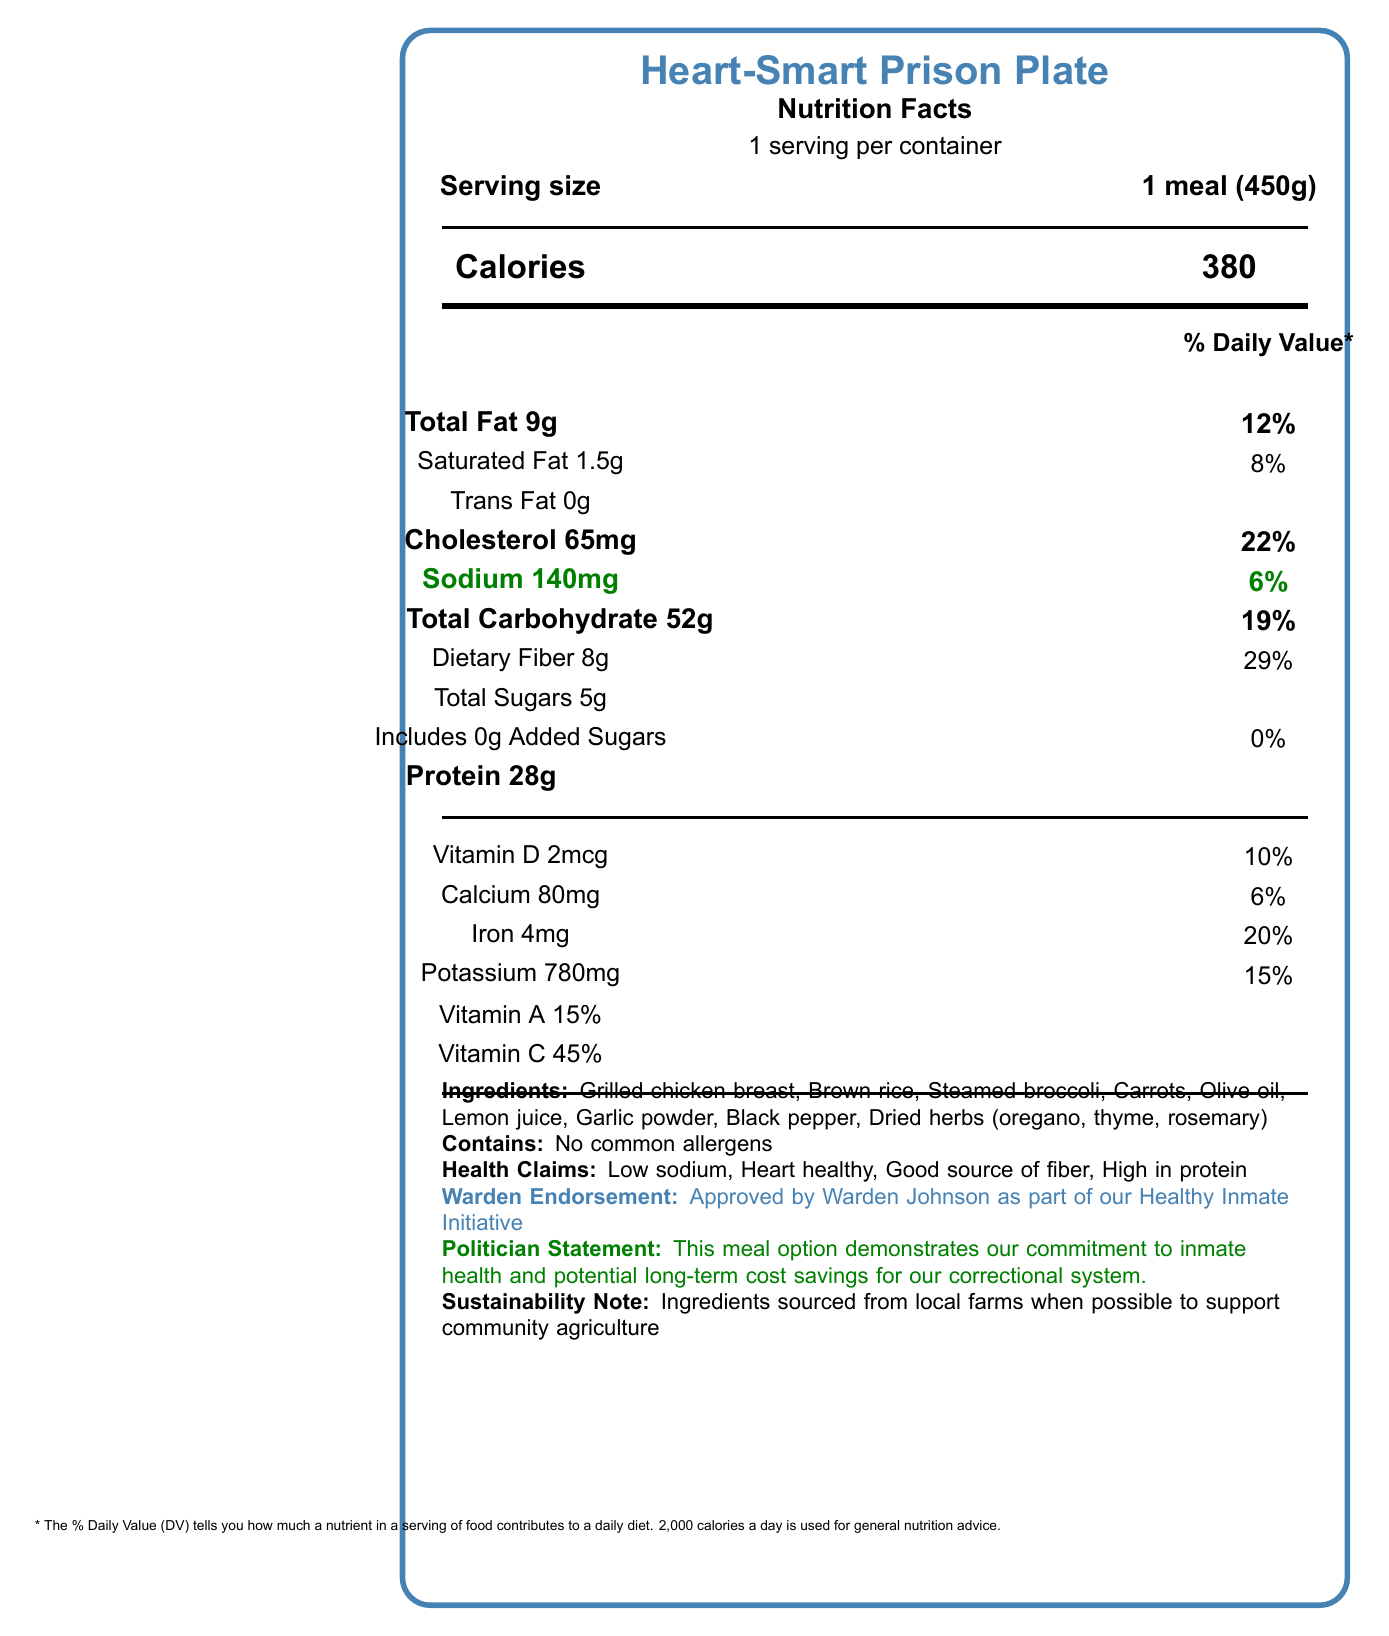what is the name of the product? The product name is located at the top of the document, labeled as "Heart-Smart Prison Plate."
Answer: Heart-Smart Prison Plate what is the serving size of this meal? The serving size is specified right below the product name, stating "1 meal (450g)."
Answer: 1 meal (450g) how many calories are in one serving? The number of calories is listed prominently under the "Calories" section as "380."
Answer: 380 how much sodium does this meal contain? The amount of sodium is highlighted in the document as "140mg," with a note that this is 6% of the daily value.
Answer: 140mg what ingredients are used in this meal? The document lists all the ingredients under the "Ingredients" section.
Answer: Grilled chicken breast, Brown rice, Steamed broccoli, Carrots, Olive oil, Lemon juice, Garlic powder, Black pepper, Dried herbs (oregano, thyme, rosemary) what health claims are associated with this meal? The health claims are listed under the "Health Claims" section of the document.
Answer: Low sodium, Heart healthy, Good source of fiber, High in protein how much protein is in one serving of this meal? The protein content is indicated under the "Protein" section as "28g."
Answer: 28g who approved this meal as part of the Healthy Inmate Initiative? The approval note from Warden Johnson is visible in the Warden Endorsement section.
Answer: Warden Johnson is this meal high in saturated fat? The meal contains 1.5g of saturated fat, which is only 8% of the daily value, making it relatively low in saturated fat.
Answer: No what is the inmate feedback score for this meal? The inmate feedback score is noted at the bottom of the document as "7.8."
Answer: 7.8 what percentage of daily fiber does this meal provide? A. 10% B. 15% C. 29% D. 45% The meal provides 29% of the daily value for dietary fiber.
Answer: C which of the following vitamins is present in the lowest amount in this meal? A. Vitamin A B. Vitamin C C. Vitamin D D. Calcium As mentioned in the document, Calcium is present at 6%, which is lower than the other listed vitamins.
Answer: D could you determine the cost of ingredients from this document? The document does not provide detailed cost information for individual ingredients.
Answer: Not enough information how does the meal support heart health? The nutrition education section clarifies this by stating the meal is designed to support heart health by being low in sodium and saturated fat and nutrient-dense.
Answer: The meal supports heart health by being low in sodium and saturated fat while providing essential nutrients like fiber and protein. describe the main idea of the document. The document includes various sections such as Nutrition Facts, ingredients, health claims, endorsements, cost information, and inmate feedback, all pointing towards the initiative's focus on improving inmate health through nutritious meal options.
Answer: The document presents the Nutrition Facts label for the Heart-Smart Prison Plate, a low-sodium and heart-healthy meal option introduced as part of the prison health initiative. It details the meal's nutritional content, ingredients, health benefits, cost, and inmate feedback. It also includes endorsements from the Warden and a statement from a politician highlighting the meal's health benefits and cost savings. 